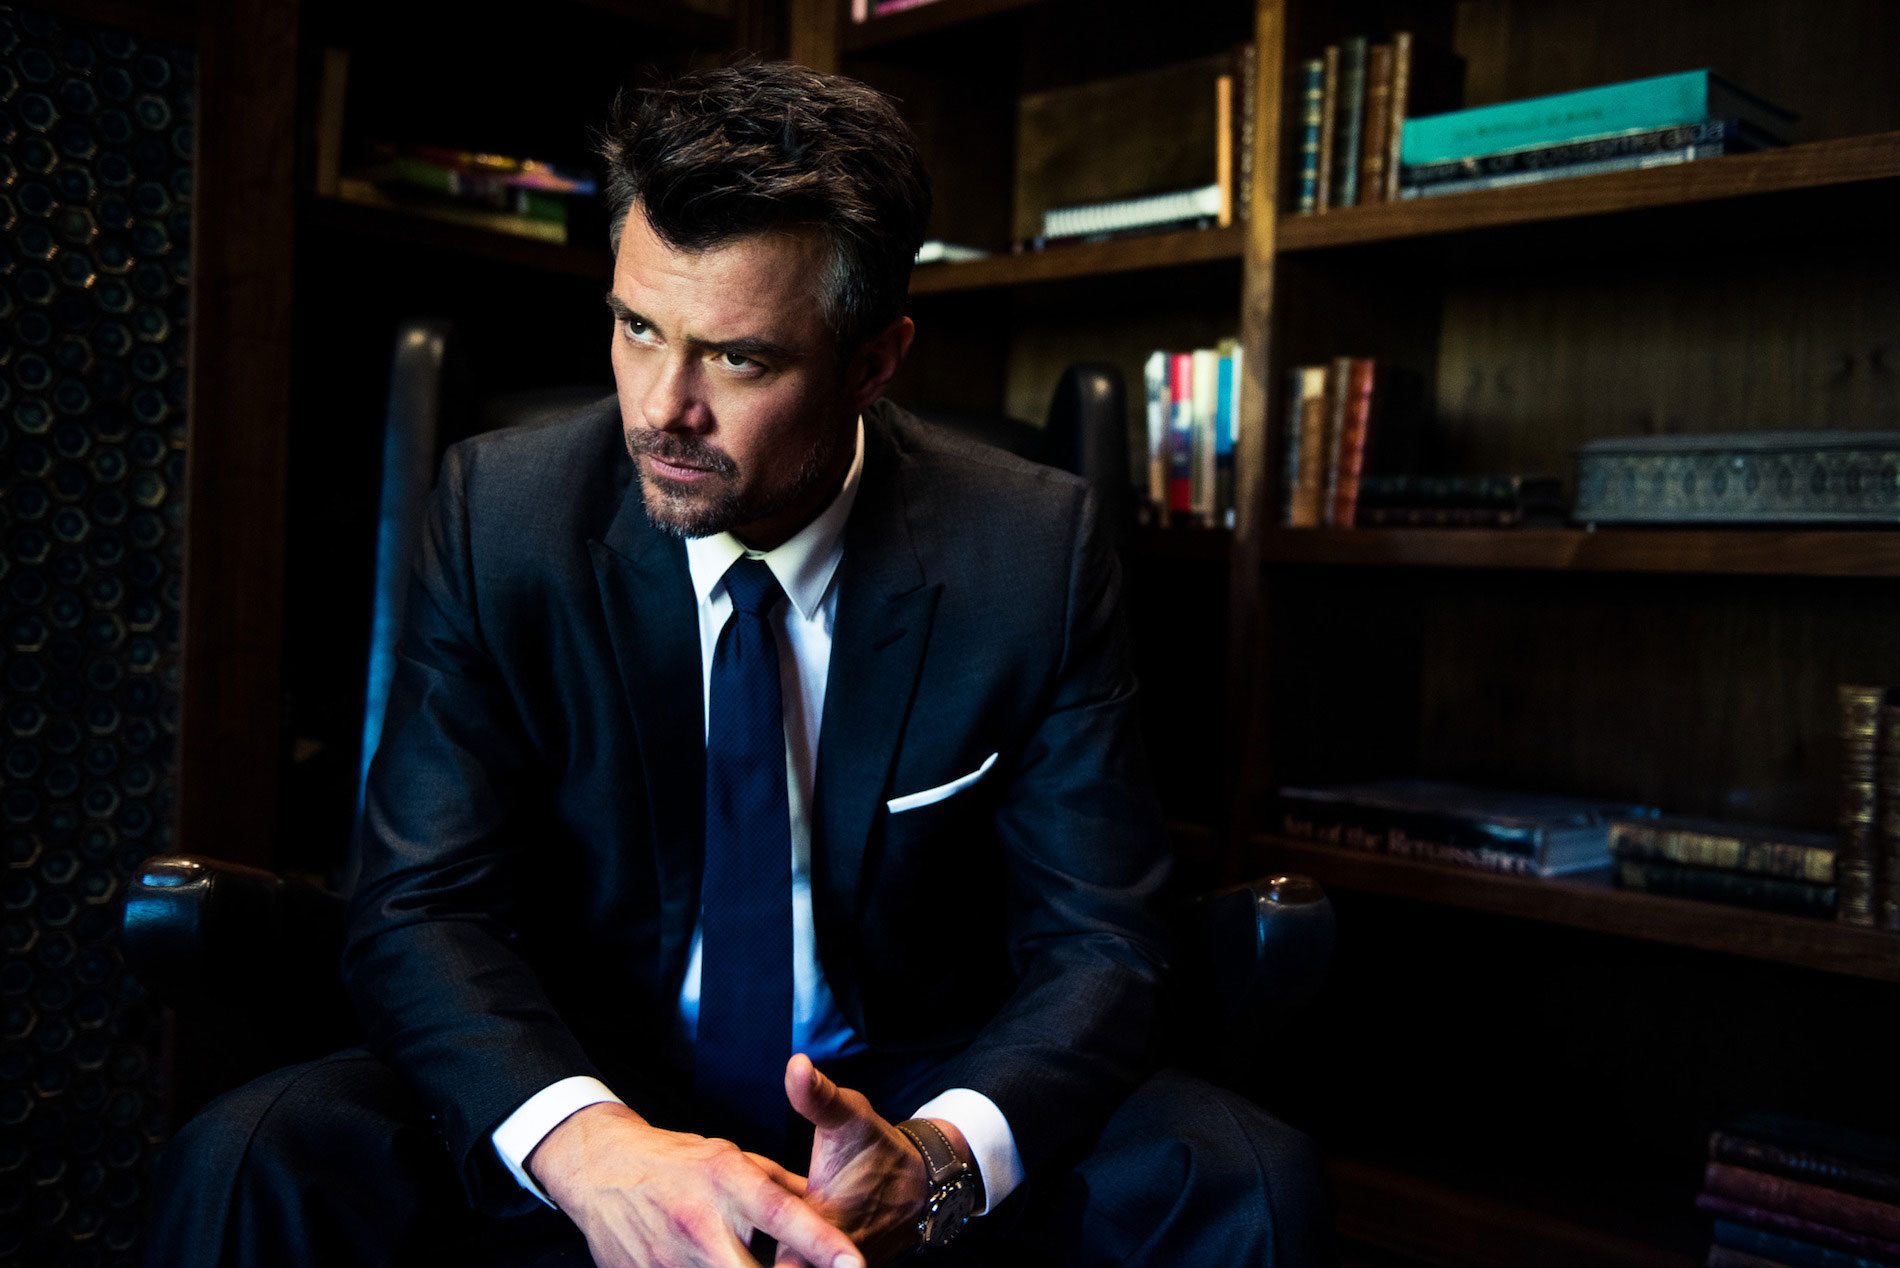What do you see happening in this image? The image portrays a man seated in an elegant armchair, likely in a private library or an office setting, surrounded by shelves filled with books. He is dressed in a dark suit and a crisp white shirt, paired with a blue tie, indicating a formal occasion or professional setting. His posture and the thoughtful look directed off-camera suggest he might be in a moment of reflection or waiting for someone. The lighting is subdued, focusing on his face and the textured back of the chair, which adds to the contemplative mood of the picture. 